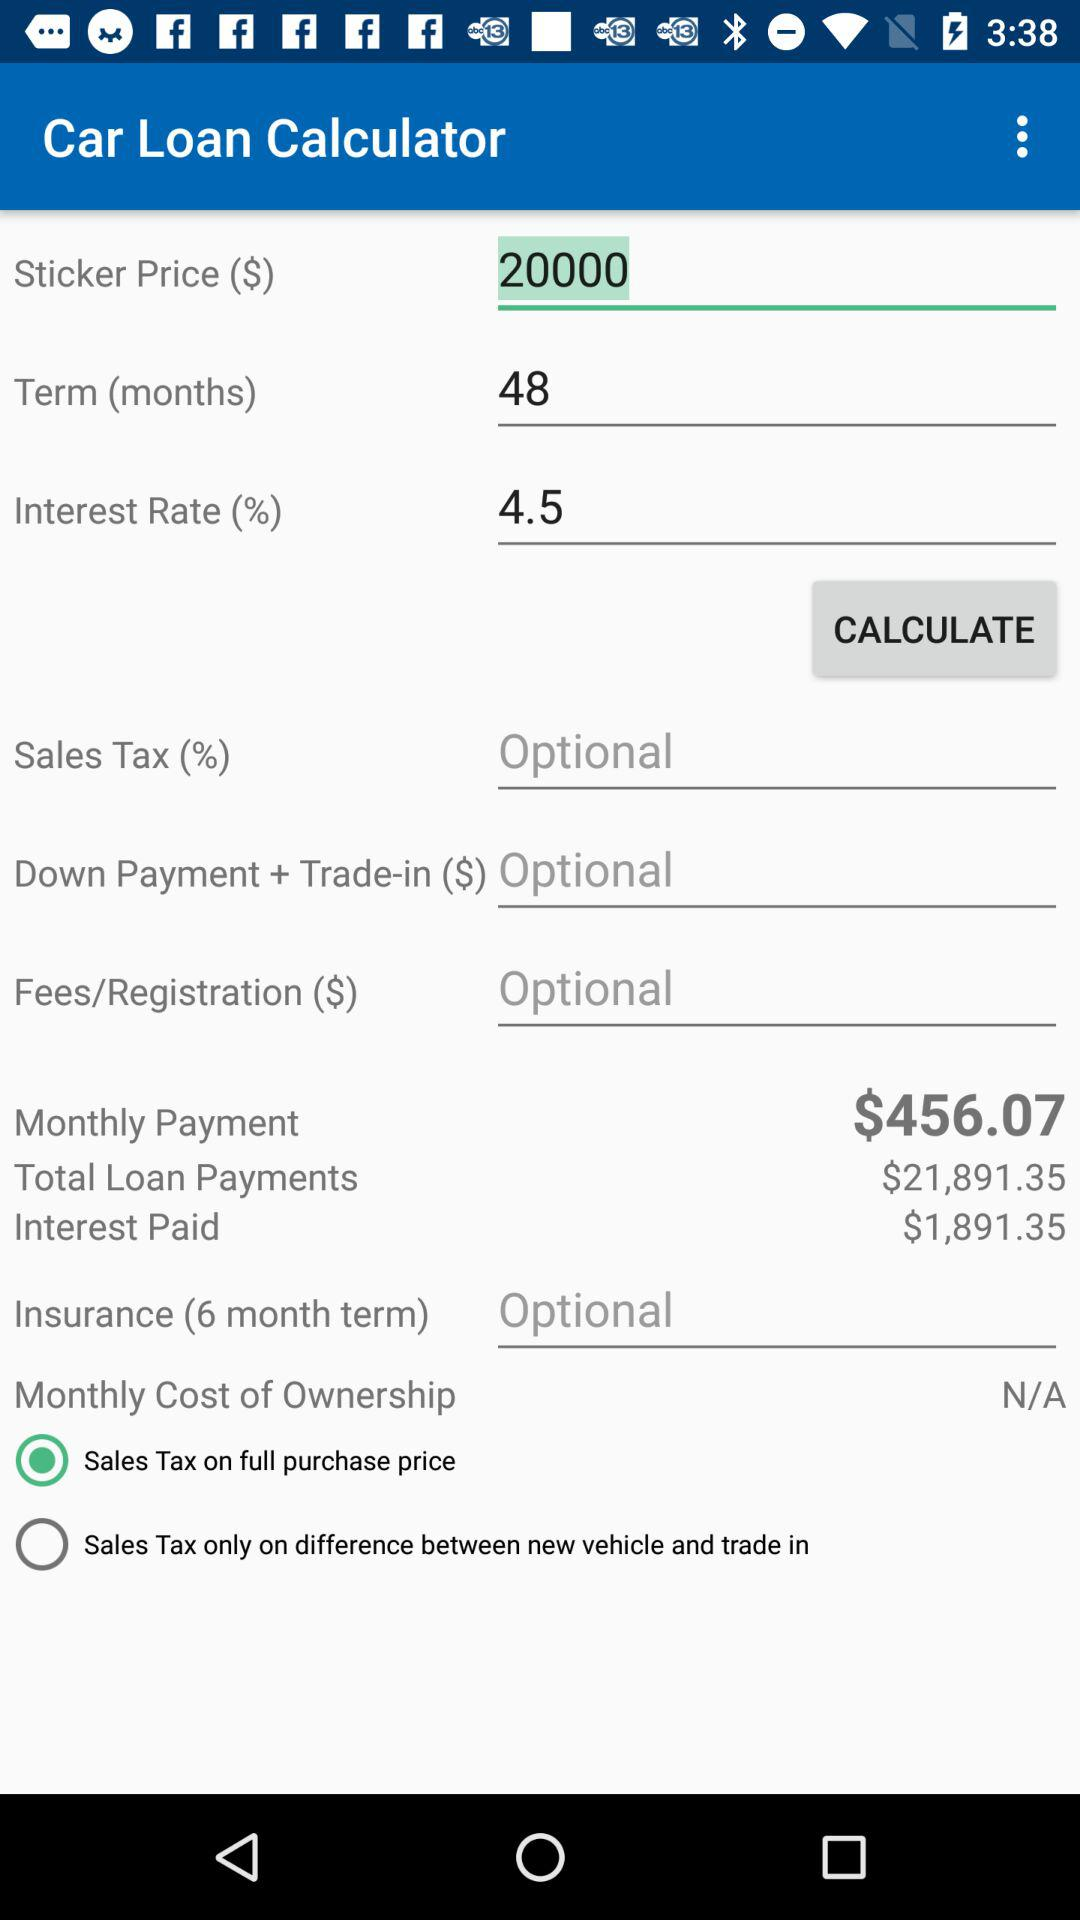How long is the term? The term is "48 months". 